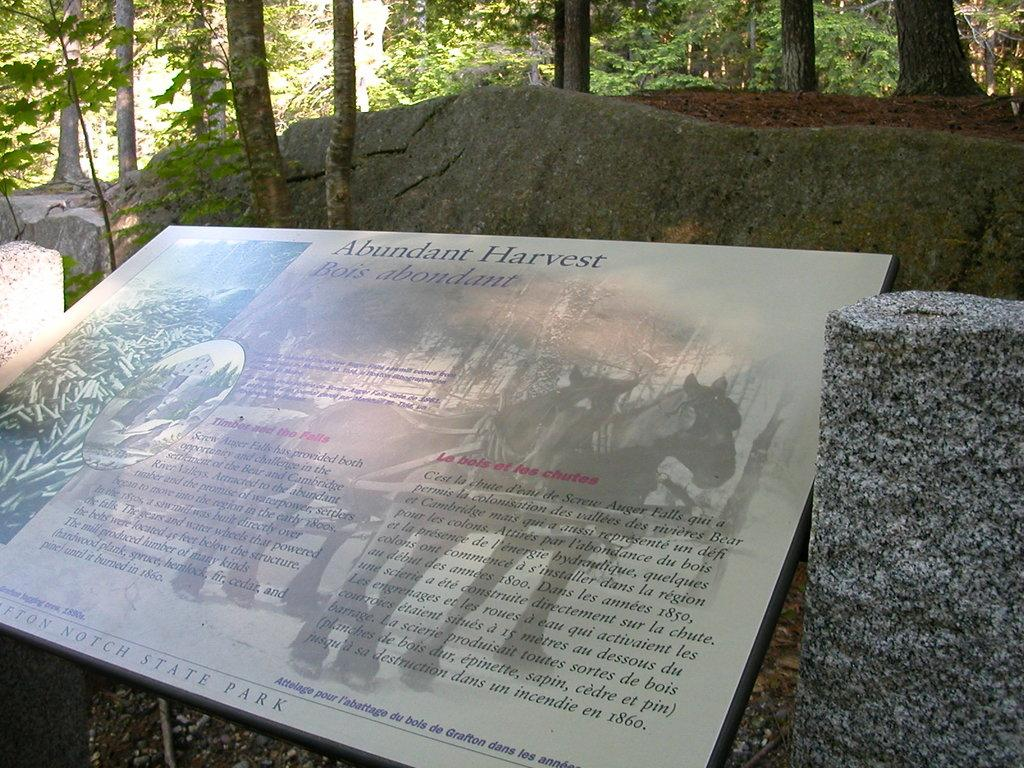What is the main object in the image? There is a board in the image. What can be found on the board? The board contains pictures of animals and text. What type of natural elements are present in the image? There are trees, plants, and rocks in the image. Can you tell me how many members are on the team in the image? There is no team present in the image; it features a board with pictures of animals and text. Is there a lake visible in the image? There is no lake present in the image; it features a board with pictures of animals and text, along with trees, plants, and rocks. 